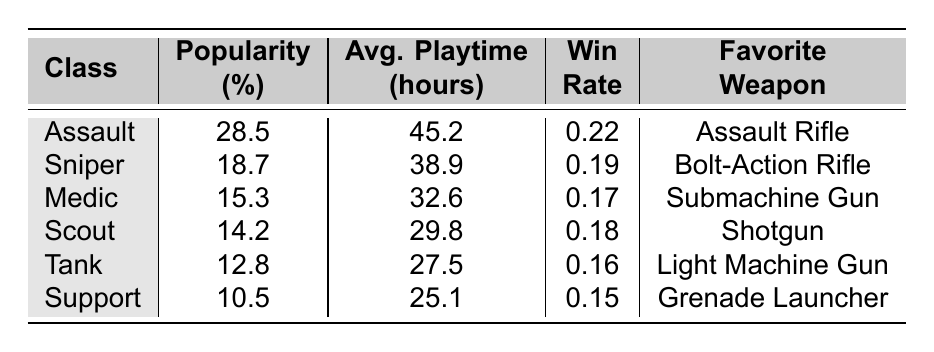What is the most popular character class? The most popular character class can be found by looking at the "Popularity (%)" column and identifying the highest value. The Assault class has a popularity percentage of 28.5%, which is the highest among all classes.
Answer: Assault What is the average playtime for the Sniper class? The average playtime for the Sniper class is explicitly listed in the "Avg. Playtime (hours)" column. For the Sniper class, this value is 38.9 hours.
Answer: 38.9 Which character class has the lowest win rate? To find the character class with the lowest win rate, look at the "Win Rate" column and identify the lowest value. The Tank class has the lowest win rate at 0.16.
Answer: Tank What is the total popularity percentage of all character classes? To calculate the total popularity percentage, sum the popularity percentages from each class. The sum of the individual percentages is 28.5 + 18.7 + 15.3 + 14.2 + 12.8 + 10.5 = 100. The total is thus 100%.
Answer: 100 Is the average playtime for the Assault class greater than that of the Medic class? Compare the average playtimes for both the Assault (45.2 hours) and Medic (32.6 hours) classes. Since 45.2 is greater than 32.6, the average playtime for the Assault class is indeed greater than that of the Medic class.
Answer: Yes Which class has a favorite weapon that is not a firearm? Review the "Favorite Weapon" column to determine which class features a weapon that is not classified as a firearm. The Support class has a Grenade Launcher, which fits this criterion.
Answer: Support What is the average win rate of all character classes combined? To find the average win rate, sum the win rates of all classes and then divide by the total number of classes. The sum is 0.22 + 0.19 + 0.17 + 0.18 + 0.16 + 0.15 = 1.07. Divide by 6 (total classes) yields 1.07 / 6 = 0.17833, which rounds to 0.18 for practical purposes.
Answer: 0.18 Which character class has a popularity percentage above 15% and a win rate above 0.20? Analyze the classes based on the criteria given. The Assault class has a popularity percentage of 28.5% and a win rate of 0.22, meeting both criteria. No other class fits these conditions.
Answer: Assault What is the difference in average playtime between the Scout and Tank classes? To find the difference, subtract the average playtime of the Tank class (27.5 hours) from that of the Scout class (29.8 hours). The difference is 29.8 - 27.5 = 2.3 hours.
Answer: 2.3 Does the Support class have the highest popularity percentage among all classes? Check the popularity percentage of the Support class (10.5%) against all other classes. Since 10.5% is not the highest, the statement is false.
Answer: No 